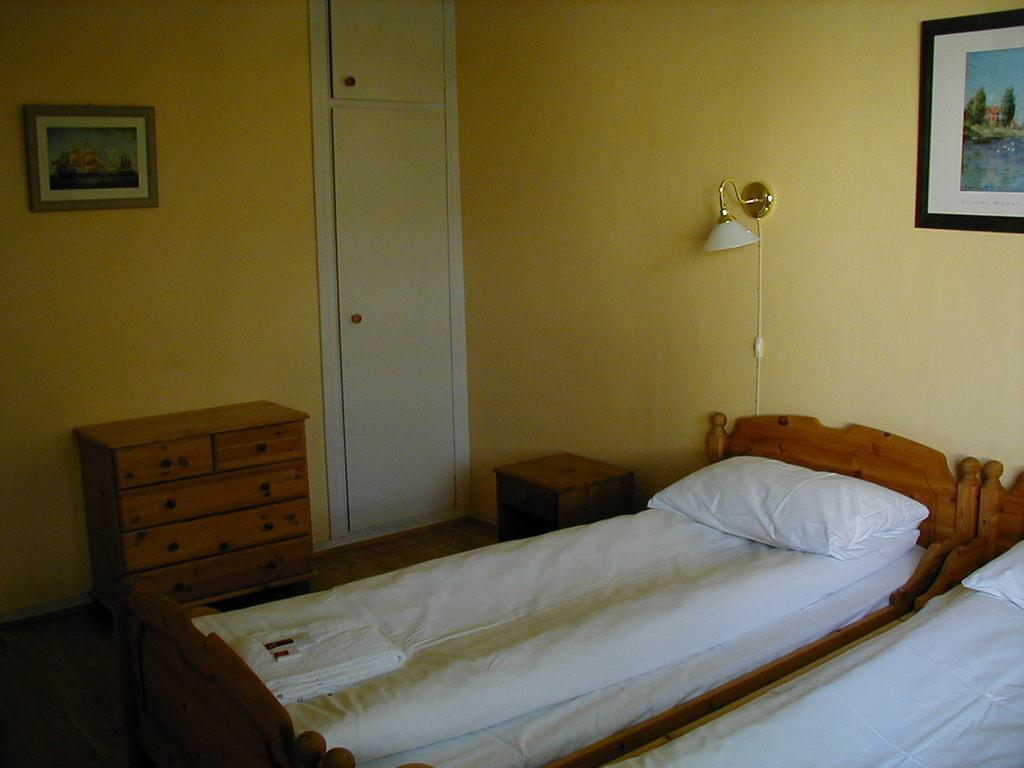What color is the wall that can be seen in the image? The wall in the image is yellow. What object is present on the wall in the image? There is a photo frame on the wall in the image. What type of lighting is visible in the image? There is a lamp in the image. How many beds are in the room depicted in the image? There are two beds in the image. What degree does the representative in the image hold? There is no representative present in the image, so it is not possible to determine their degree. 